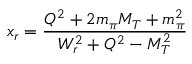<formula> <loc_0><loc_0><loc_500><loc_500>x _ { r } = \frac { Q ^ { 2 } + 2 m _ { \pi } M _ { T } + m _ { \pi } ^ { 2 } } { W _ { r } ^ { 2 } + Q ^ { 2 } - M _ { T } ^ { 2 } }</formula> 